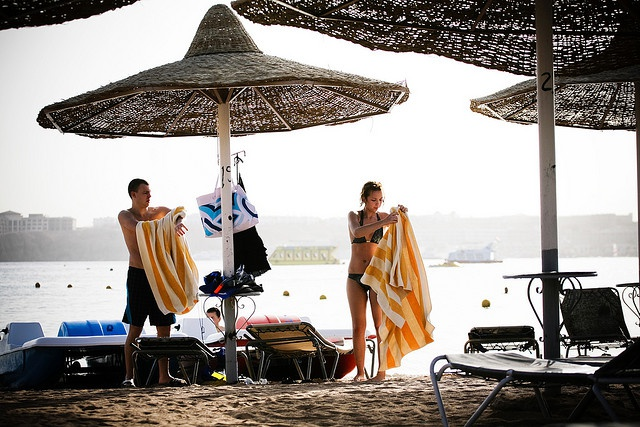Describe the objects in this image and their specific colors. I can see umbrella in black, gray, darkgray, and white tones, umbrella in black, gray, white, and darkgray tones, chair in black, lightgray, gray, and darkgray tones, people in black, brown, tan, maroon, and red tones, and people in black, brown, maroon, and tan tones in this image. 